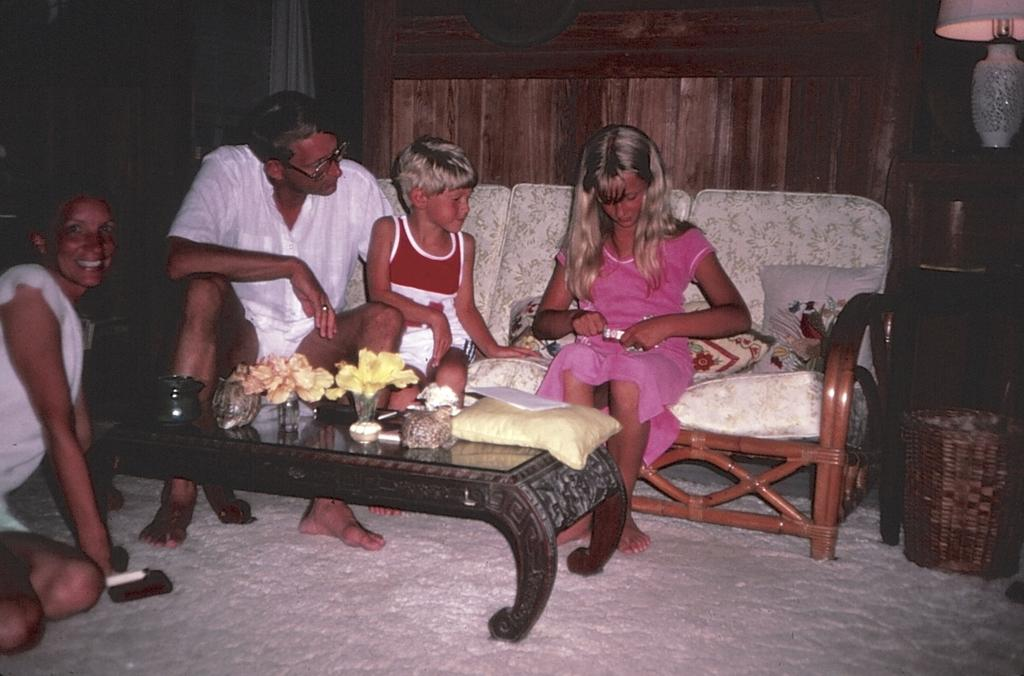How many adults are in the room? There are two adults in the room. How many children are in the room? There are two children in the room. What type of cars can be seen in the room? There are no cars present in the room; it contains two adults and two children. What rule is being enforced in the room? The provided facts do not mention any rules being enforced in the room. 